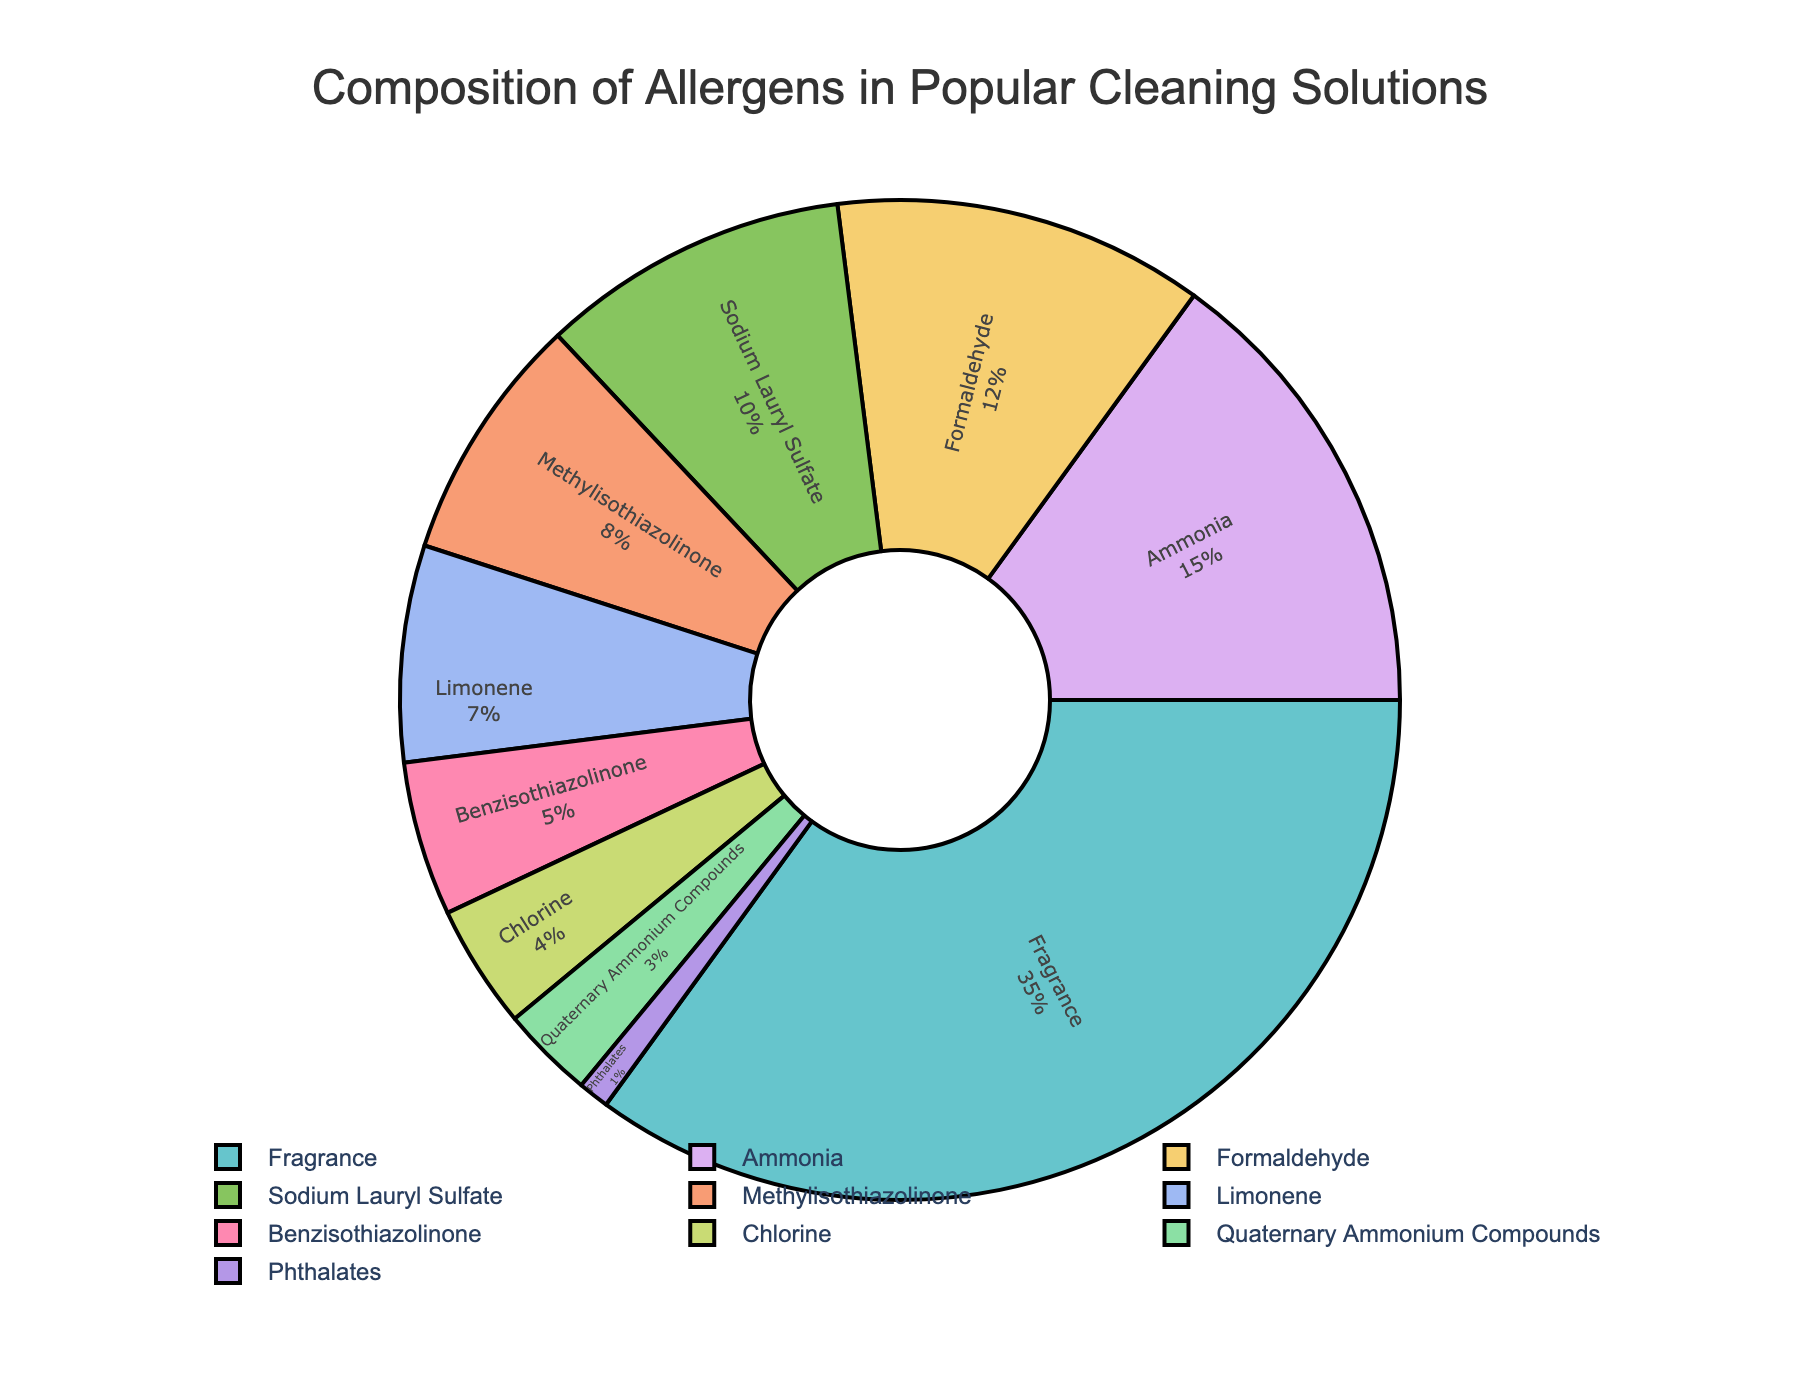What percentage of allergens is contributed by Ammonia and Formaldehyde together? To find the combined percentage of Ammonia and Formaldehyde, add their individual percentages: Ammonia (15%) + Formaldehyde (12%) = 27%.
Answer: 27% Which allergen has the highest contribution and what is that percentage? Identify the allergen with the largest single percentage slice on the pie chart. Fragrance has the highest contribution at 35%.
Answer: Fragrance, 35% Is the percentage of Benzisothiazolinone more than that of Limonene? Compare the percentages of Benzisothiazolinone (5%) and Limonene (7%). Limonene has a higher percentage.
Answer: No Which allergens have a percentage contribution greater than 10%? Look for allergens with percentages more than 10%: Fragrance (35%), Ammonia (15%), Formaldehyde (12%).
Answer: Fragrance, Ammonia, Formaldehyde What is the combined percentage of allergens with less than 5% contribution? Sum the percentages of Chlorine (4%), Quaternary Ammonium Compounds (3%), and Phthalates (1%): 4% + 3% + 1% = 8%.
Answer: 8% By how much is the percentage of Fragrance higher than that of Sodium Lauryl Sulfate? Subtract the percentage of Sodium Lauryl Sulfate (10%) from the percentage of Fragrance (35%): 35% - 10% = 25%.
Answer: 25% Which allergen appears to have the smallest slice on the pie chart and what is its percentage? Identify the smallest slice on the pie chart, which belongs to Phthalates. Phthalates have the smallest contribution at 1%.
Answer: Phthalates, 1% How do the percentages of Methylisothiazolinone and Limonene compare? Compare the percentages directly: Methylisothiazolinone (8%) versus Limonene (7%). Methylisothiazolinone has a higher percentage.
Answer: Methylisothiazolinone has a higher percentage than Limonene What is the visual appearance (color) mostly assigned to the largest slice (Fragrance) on the pie chart? Observing the color assigned to Fragrance, the largest slice on the pie chart, it uses the first color in the custom palette which is light.
Answer: Light shade (like Pastel) 